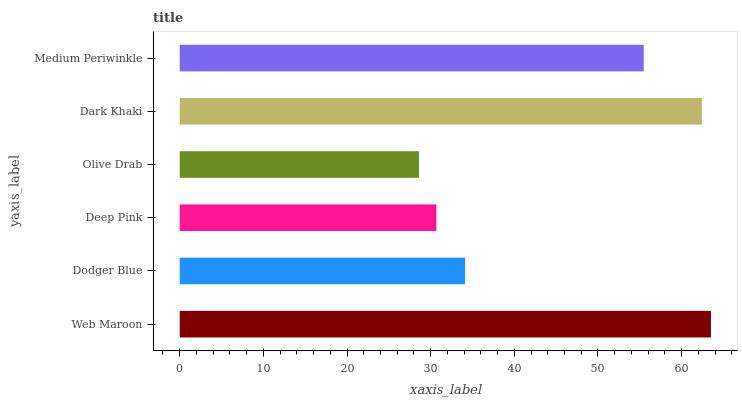Is Olive Drab the minimum?
Answer yes or no. Yes. Is Web Maroon the maximum?
Answer yes or no. Yes. Is Dodger Blue the minimum?
Answer yes or no. No. Is Dodger Blue the maximum?
Answer yes or no. No. Is Web Maroon greater than Dodger Blue?
Answer yes or no. Yes. Is Dodger Blue less than Web Maroon?
Answer yes or no. Yes. Is Dodger Blue greater than Web Maroon?
Answer yes or no. No. Is Web Maroon less than Dodger Blue?
Answer yes or no. No. Is Medium Periwinkle the high median?
Answer yes or no. Yes. Is Dodger Blue the low median?
Answer yes or no. Yes. Is Web Maroon the high median?
Answer yes or no. No. Is Medium Periwinkle the low median?
Answer yes or no. No. 